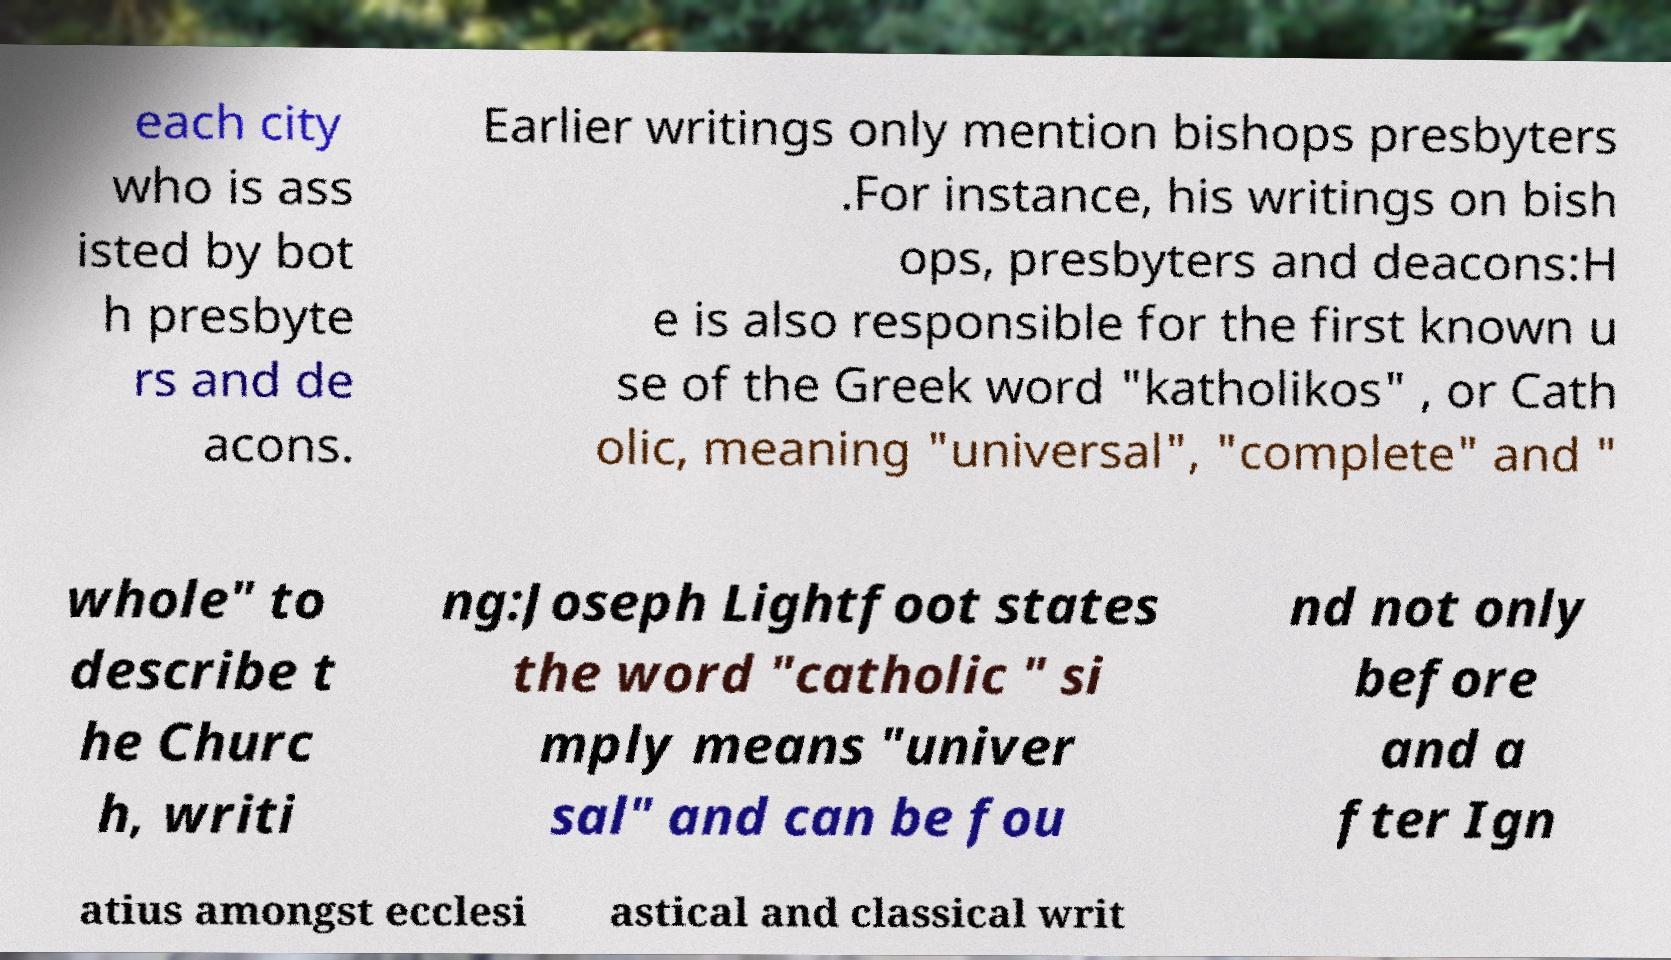Please read and relay the text visible in this image. What does it say? each city who is ass isted by bot h presbyte rs and de acons. Earlier writings only mention bishops presbyters .For instance, his writings on bish ops, presbyters and deacons:H e is also responsible for the first known u se of the Greek word "katholikos" , or Cath olic, meaning "universal", "complete" and " whole" to describe t he Churc h, writi ng:Joseph Lightfoot states the word "catholic " si mply means "univer sal" and can be fou nd not only before and a fter Ign atius amongst ecclesi astical and classical writ 